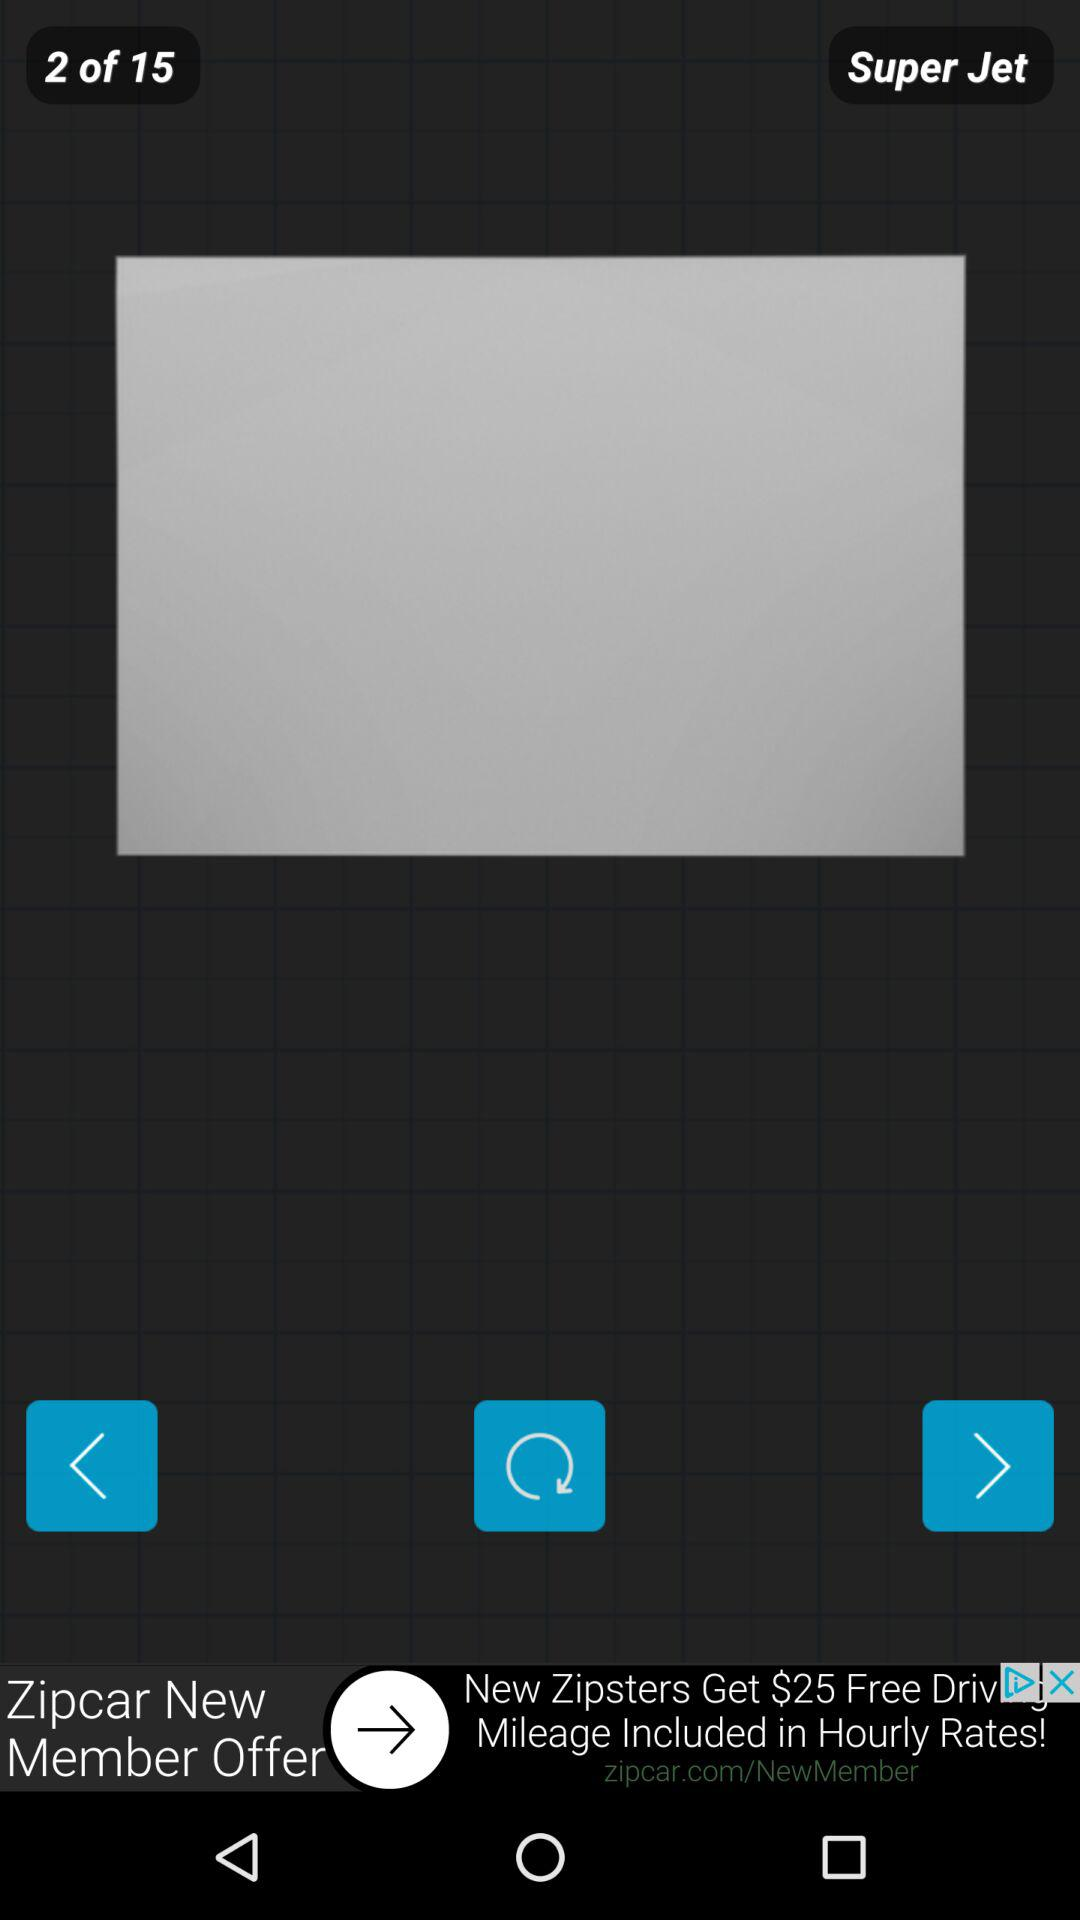How many pages in total are there? There are 15 pages in total. 